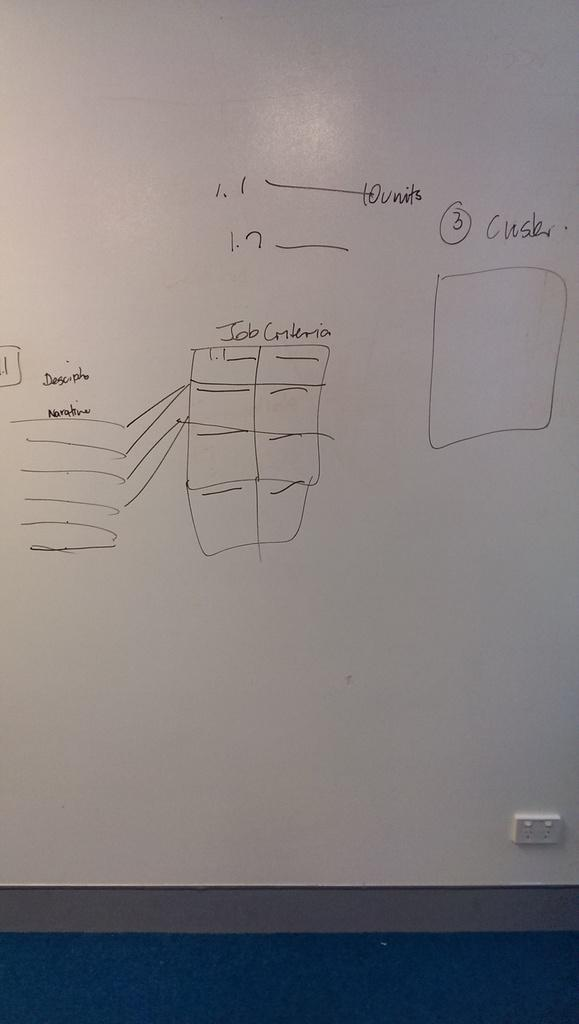<image>
Write a terse but informative summary of the picture. A whiteboard with a table for job criteria. 